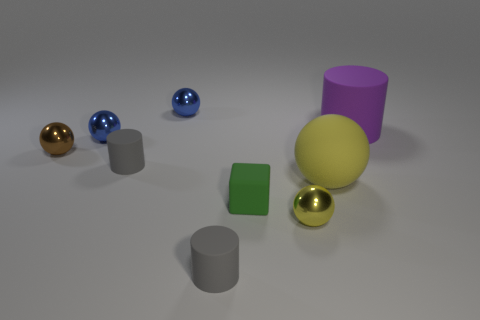Add 1 big cyan shiny blocks. How many objects exist? 10 Subtract all purple matte cylinders. How many cylinders are left? 2 Add 9 brown metal objects. How many brown metal objects exist? 10 Subtract all gray cylinders. How many cylinders are left? 1 Subtract 0 purple cubes. How many objects are left? 9 Subtract all spheres. How many objects are left? 4 Subtract 3 balls. How many balls are left? 2 Subtract all gray spheres. Subtract all cyan blocks. How many spheres are left? 5 Subtract all green spheres. How many cyan blocks are left? 0 Subtract all yellow metallic things. Subtract all balls. How many objects are left? 3 